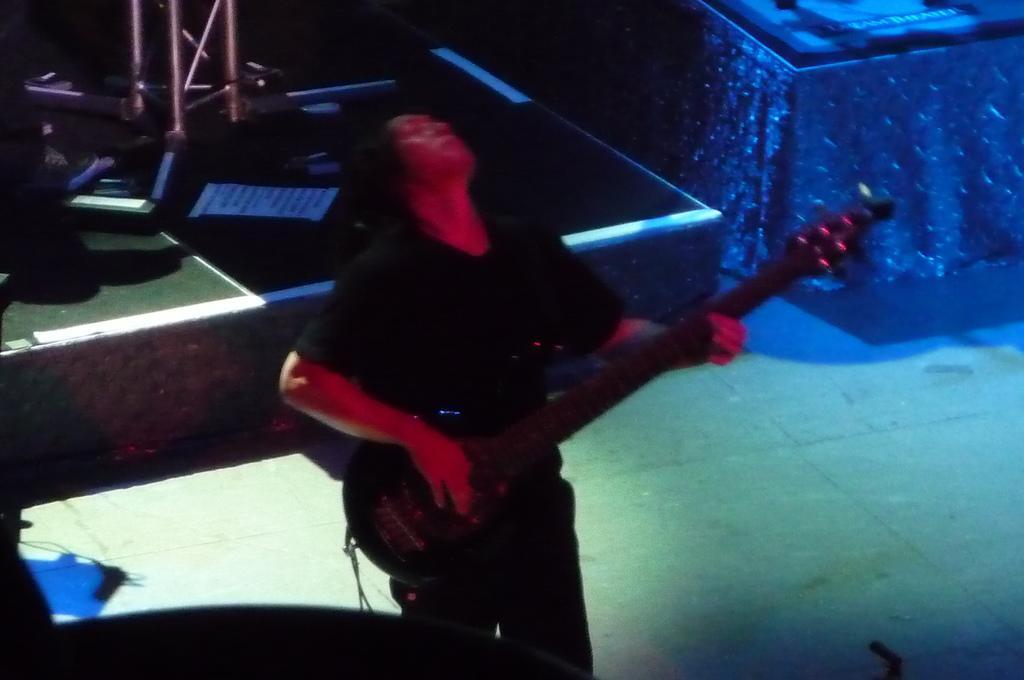Describe this image in one or two sentences. A person wearing a black dress is holding a guitar and playing. Behind it there is a stage and some stands are kept over there. 